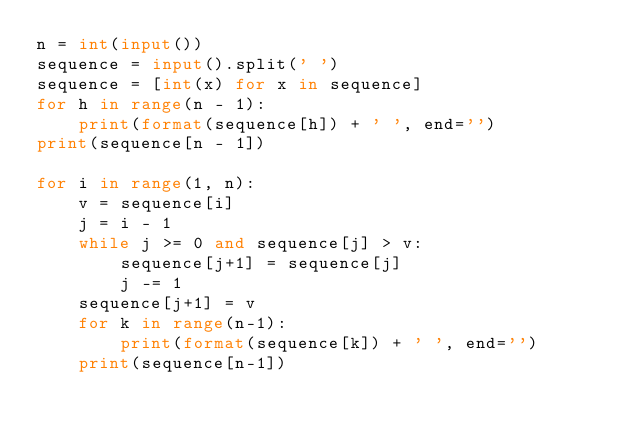<code> <loc_0><loc_0><loc_500><loc_500><_Python_>n = int(input())
sequence = input().split(' ')
sequence = [int(x) for x in sequence]
for h in range(n - 1):
    print(format(sequence[h]) + ' ', end='')
print(sequence[n - 1])

for i in range(1, n):
    v = sequence[i]
    j = i - 1
    while j >= 0 and sequence[j] > v:
        sequence[j+1] = sequence[j]
        j -= 1
    sequence[j+1] = v
    for k in range(n-1):
        print(format(sequence[k]) + ' ', end='')
    print(sequence[n-1])</code> 